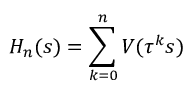<formula> <loc_0><loc_0><loc_500><loc_500>H _ { n } ( s ) = \sum _ { k = 0 } ^ { n } V ( \tau ^ { k } s )</formula> 